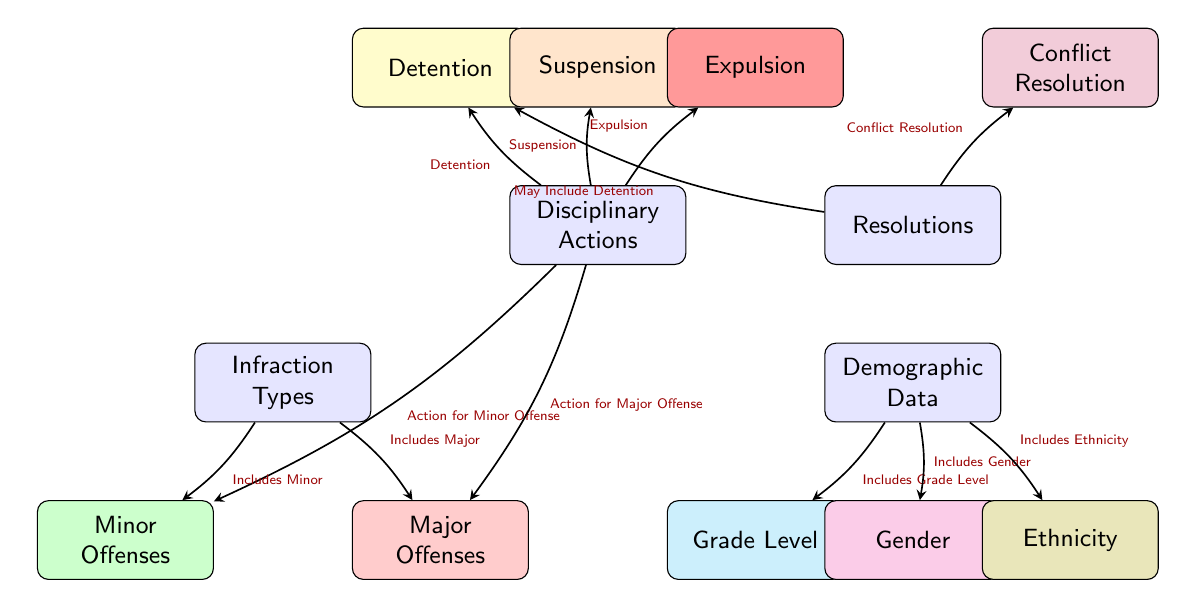What are the main categories of disciplinary actions in this diagram? The diagram clearly outlines two main categories of disciplinary actions: 'Detention' and 'Suspension' are notable, but 'Expulsion' is also there. These are positioned under 'Resolutions' connected to 'Disciplinary Actions'.
Answer: Detention, Suspension, Expulsion How many infraction types are shown in the diagram? The diagram includes two types of infractions: 'Minor Offenses' and 'Major Offenses'. They are located under the infraction types node. Thus, the total number is two.
Answer: 2 Which demographic data categories are specified in the diagram? The diagram lists three categories of demographic data. These are 'Grade Level', 'Gender', and 'Ethnicity', which branch out from the 'Demographic Data' node.
Answer: Grade Level, Gender, Ethnicity What disciplinary action is connected to major offenses? The 'Major Offenses' node is directly connected to the 'Disciplinary Actions' node, leading to multiple outcomes. Specifically, it is linked to 'Detention', 'Suspension', and 'Expulsion' as actions that follow major offenses.
Answer: Detention, Suspension, Expulsion Is conflict resolution a possible resolution for disciplinary actions? Yes, 'Conflict Resolution' is listed under the 'Resolutions' node, indicating that it is indeed a potential method of resolving issues arising from disciplinary actions, as it is connected to the 'Resolutions' node.
Answer: Yes What is the flow of action for minor offenses leading to disciplinary actions? The diagram shows that actions for minor offenses come from the 'Disciplinary Actions' node, pointing specifically to 'Detention' and 'Suspension'. This means that minor offenses can be resolved primarily with these actions.
Answer: Detention, Suspension Which infraction types include grade level information? The 'Grade Level' demographic data is indicated to be connected to the 'Infraction Types' node. It implies that both 'Minor Offenses' and 'Major Offenses' categories may consider grade level for their respective actions.
Answer: Minor Offenses, Major Offenses How does the diagram categorize the severity of offenses? The diagram uses colors and node placement to categorize offenses into 'Minor Offenses' (green) and 'Major Offenses' (red). This clearly illustrates the different severity levels across disciplinary actions.
Answer: Minor Offenses, Major Offenses What type of action is labeled as 'May Include Detention'? The flow indicates that 'May Include Detention' is a possible resolution under the 'Resolutions' node that relates to actions stemming from the 'Disciplinary Actions'. This means that certain situations may lead to detention as a consequence.
Answer: Detention 